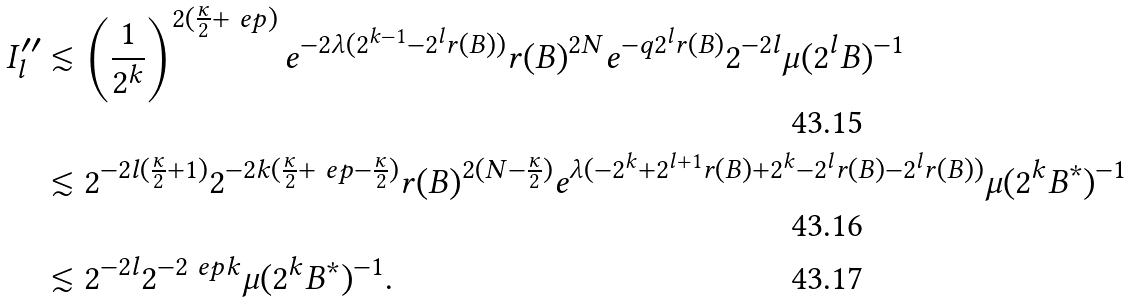<formula> <loc_0><loc_0><loc_500><loc_500>I _ { l } ^ { \prime \prime } & \lesssim \left ( \frac { 1 } { 2 ^ { k } } \right ) ^ { 2 ( \frac { \kappa } { 2 } + \ e p ) } e ^ { - 2 \lambda ( 2 ^ { k - 1 } - 2 ^ { l } r ( B ) ) } { r ( B ) } ^ { 2 N } e ^ { - q 2 ^ { l } r ( B ) } 2 ^ { - 2 l } \mu ( 2 ^ { l } B ) ^ { - 1 } \\ & \lesssim 2 ^ { - 2 l ( \frac { \kappa } { 2 } + 1 ) } 2 ^ { - 2 k ( \frac { \kappa } { 2 } + \ e p - \frac { \kappa } { 2 } ) } { r ( B ) } ^ { 2 ( N - \frac { \kappa } { 2 } ) } e ^ { \lambda ( - 2 ^ { k } + 2 ^ { l + 1 } { r ( B ) } + 2 ^ { k } - 2 ^ { l } r ( B ) - 2 ^ { l } r ( B ) ) } \mu ( 2 ^ { k } B ^ { * } ) ^ { - 1 } \\ & \lesssim 2 ^ { - 2 l } 2 ^ { - 2 \ e p k } \mu ( 2 ^ { k } B ^ { * } ) ^ { - 1 } .</formula> 